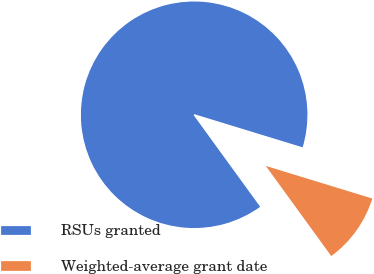<chart> <loc_0><loc_0><loc_500><loc_500><pie_chart><fcel>RSUs granted<fcel>Weighted-average grant date<nl><fcel>89.72%<fcel>10.28%<nl></chart> 